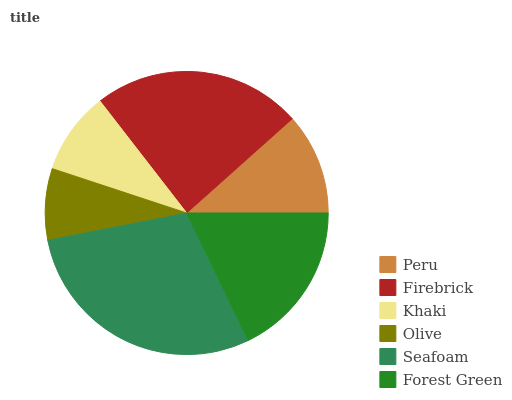Is Olive the minimum?
Answer yes or no. Yes. Is Seafoam the maximum?
Answer yes or no. Yes. Is Firebrick the minimum?
Answer yes or no. No. Is Firebrick the maximum?
Answer yes or no. No. Is Firebrick greater than Peru?
Answer yes or no. Yes. Is Peru less than Firebrick?
Answer yes or no. Yes. Is Peru greater than Firebrick?
Answer yes or no. No. Is Firebrick less than Peru?
Answer yes or no. No. Is Forest Green the high median?
Answer yes or no. Yes. Is Peru the low median?
Answer yes or no. Yes. Is Peru the high median?
Answer yes or no. No. Is Firebrick the low median?
Answer yes or no. No. 